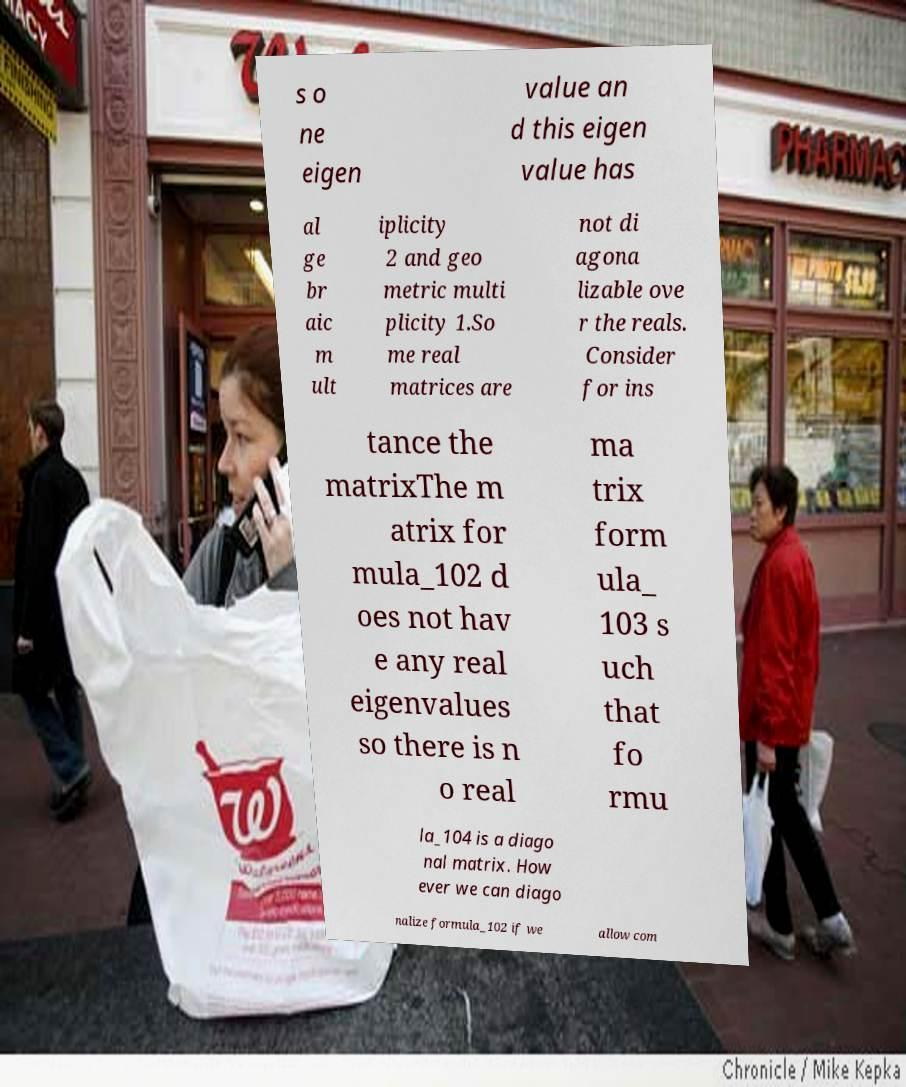For documentation purposes, I need the text within this image transcribed. Could you provide that? s o ne eigen value an d this eigen value has al ge br aic m ult iplicity 2 and geo metric multi plicity 1.So me real matrices are not di agona lizable ove r the reals. Consider for ins tance the matrixThe m atrix for mula_102 d oes not hav e any real eigenvalues so there is n o real ma trix form ula_ 103 s uch that fo rmu la_104 is a diago nal matrix. How ever we can diago nalize formula_102 if we allow com 